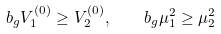<formula> <loc_0><loc_0><loc_500><loc_500>b _ { g } V _ { 1 } ^ { ( 0 ) } \geq V _ { 2 } ^ { ( 0 ) } , \quad b _ { g } \mu _ { 1 } ^ { 2 } \geq \mu _ { 2 } ^ { 2 }</formula> 